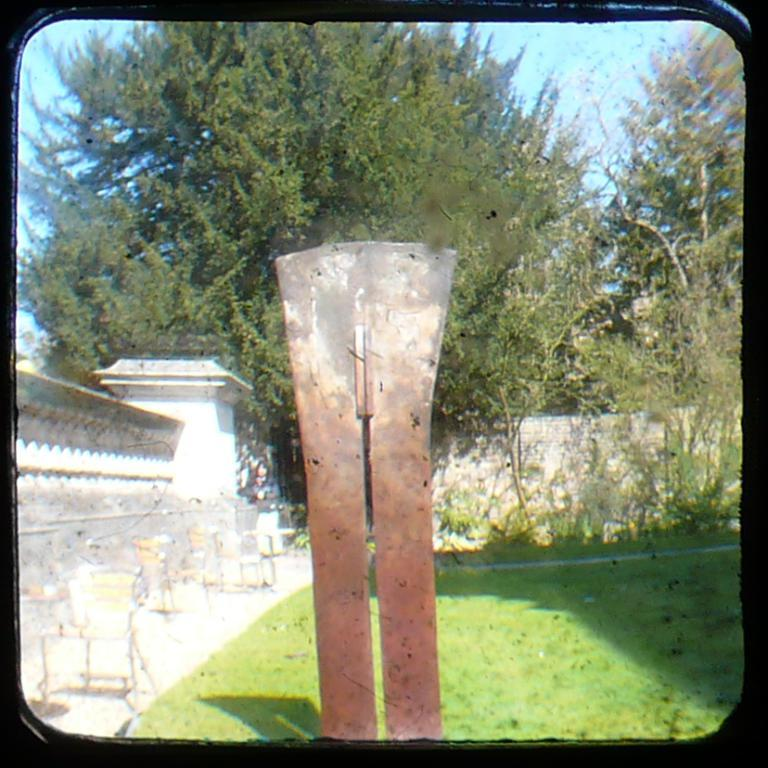What objects are in the foreground of the picture? There are chairs and tables in the foreground of the picture. What type of natural environment is visible in the foreground of the picture? Grass and plants are visible in the foreground of the picture. What can be seen in the background of the picture? There are trees in the background of the picture. What is the condition of the sky in the picture? The sky is clear and it is sunny in the picture. How many police officers are visible in the picture? There are no police officers present in the picture. What type of chickens can be seen roaming around in the picture? There are no chickens present in the picture. 